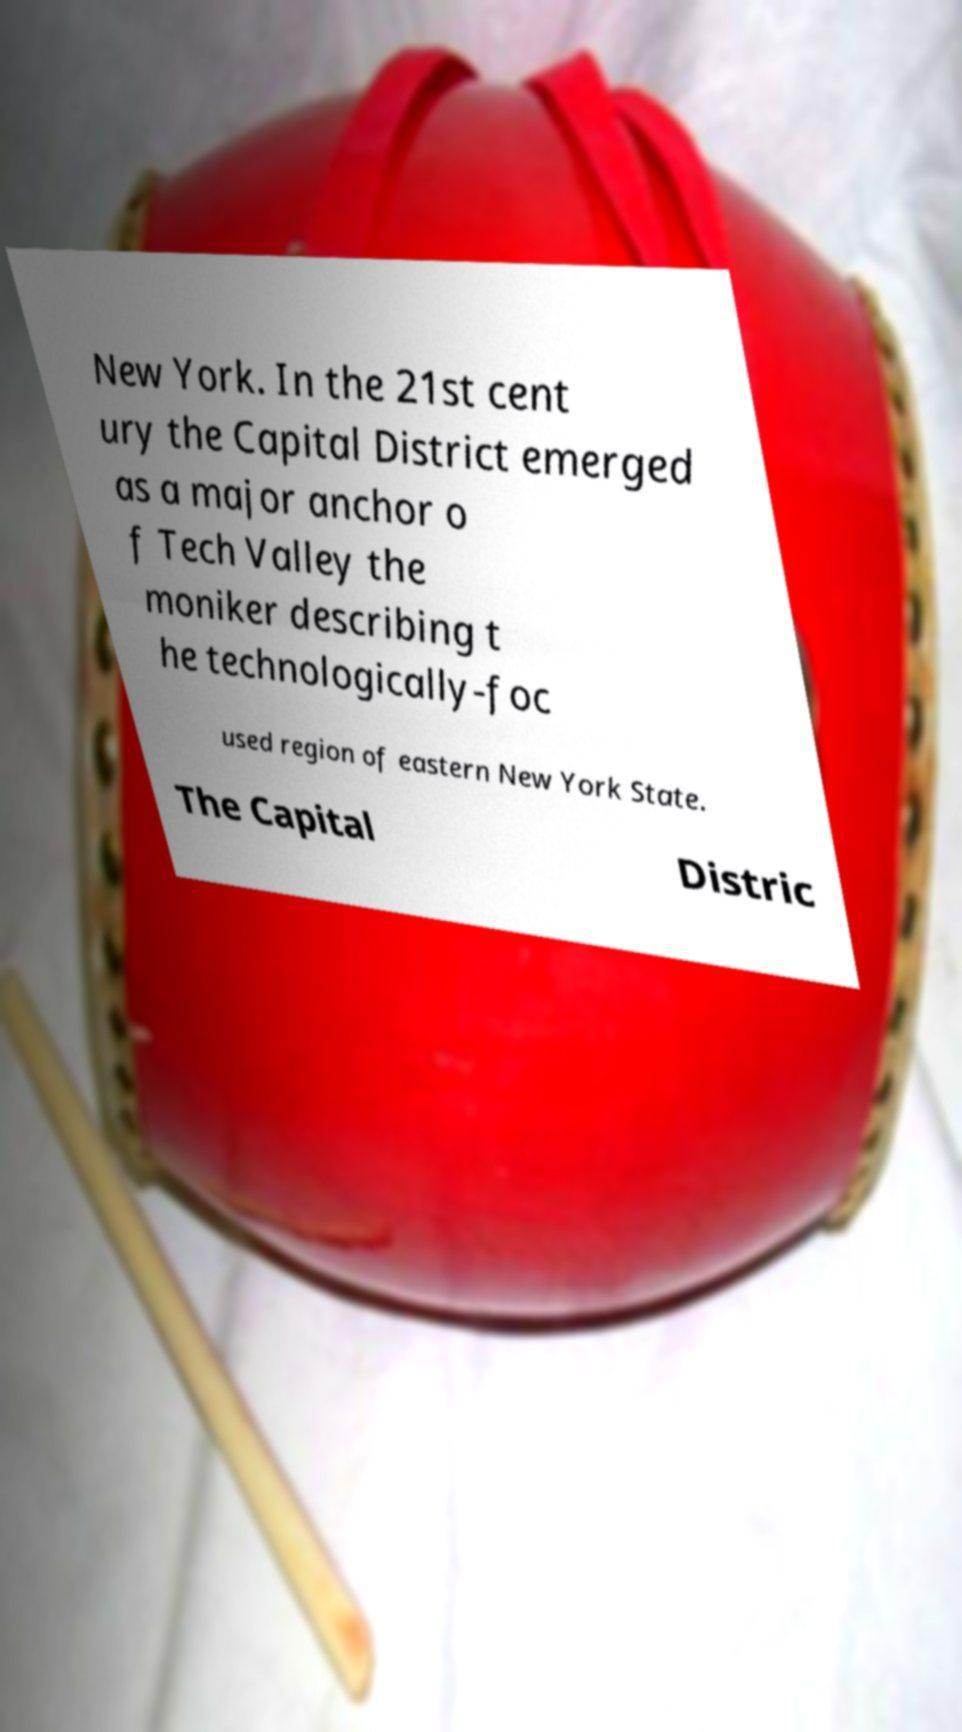There's text embedded in this image that I need extracted. Can you transcribe it verbatim? New York. In the 21st cent ury the Capital District emerged as a major anchor o f Tech Valley the moniker describing t he technologically-foc used region of eastern New York State. The Capital Distric 